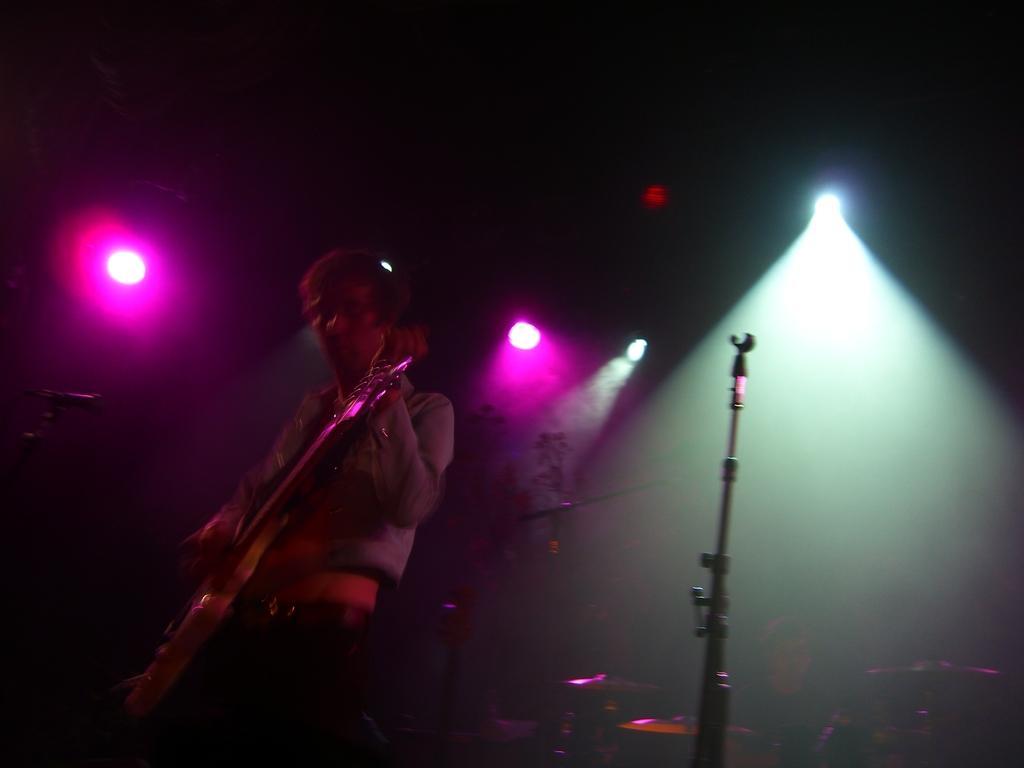Could you give a brief overview of what you see in this image? This image consists of a person playing guitar. It is clicked in a concert. To the right, there is a stand. In the background, there are few lights. 